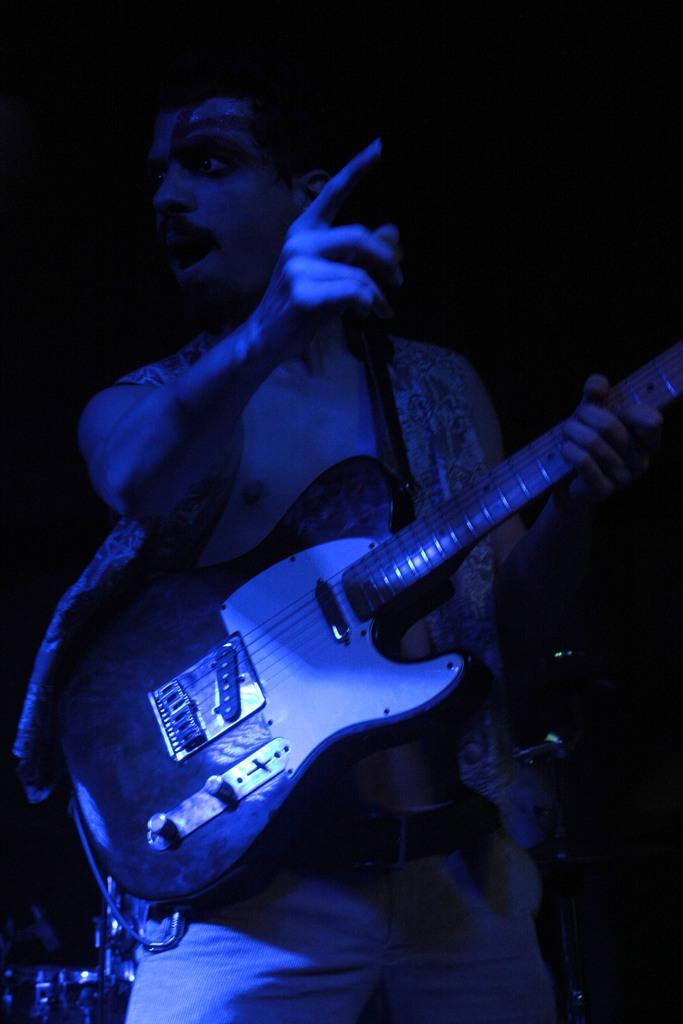Can you describe this image briefly? In the middle of the image a man is standing and holding a guitar. 